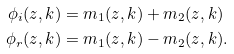<formula> <loc_0><loc_0><loc_500><loc_500>\phi _ { i } ( z , k ) & = m _ { 1 } ( z , k ) + m _ { 2 } ( z , k ) \\ \phi _ { r } ( z , k ) & = m _ { 1 } ( z , k ) - m _ { 2 } ( z , k ) .</formula> 